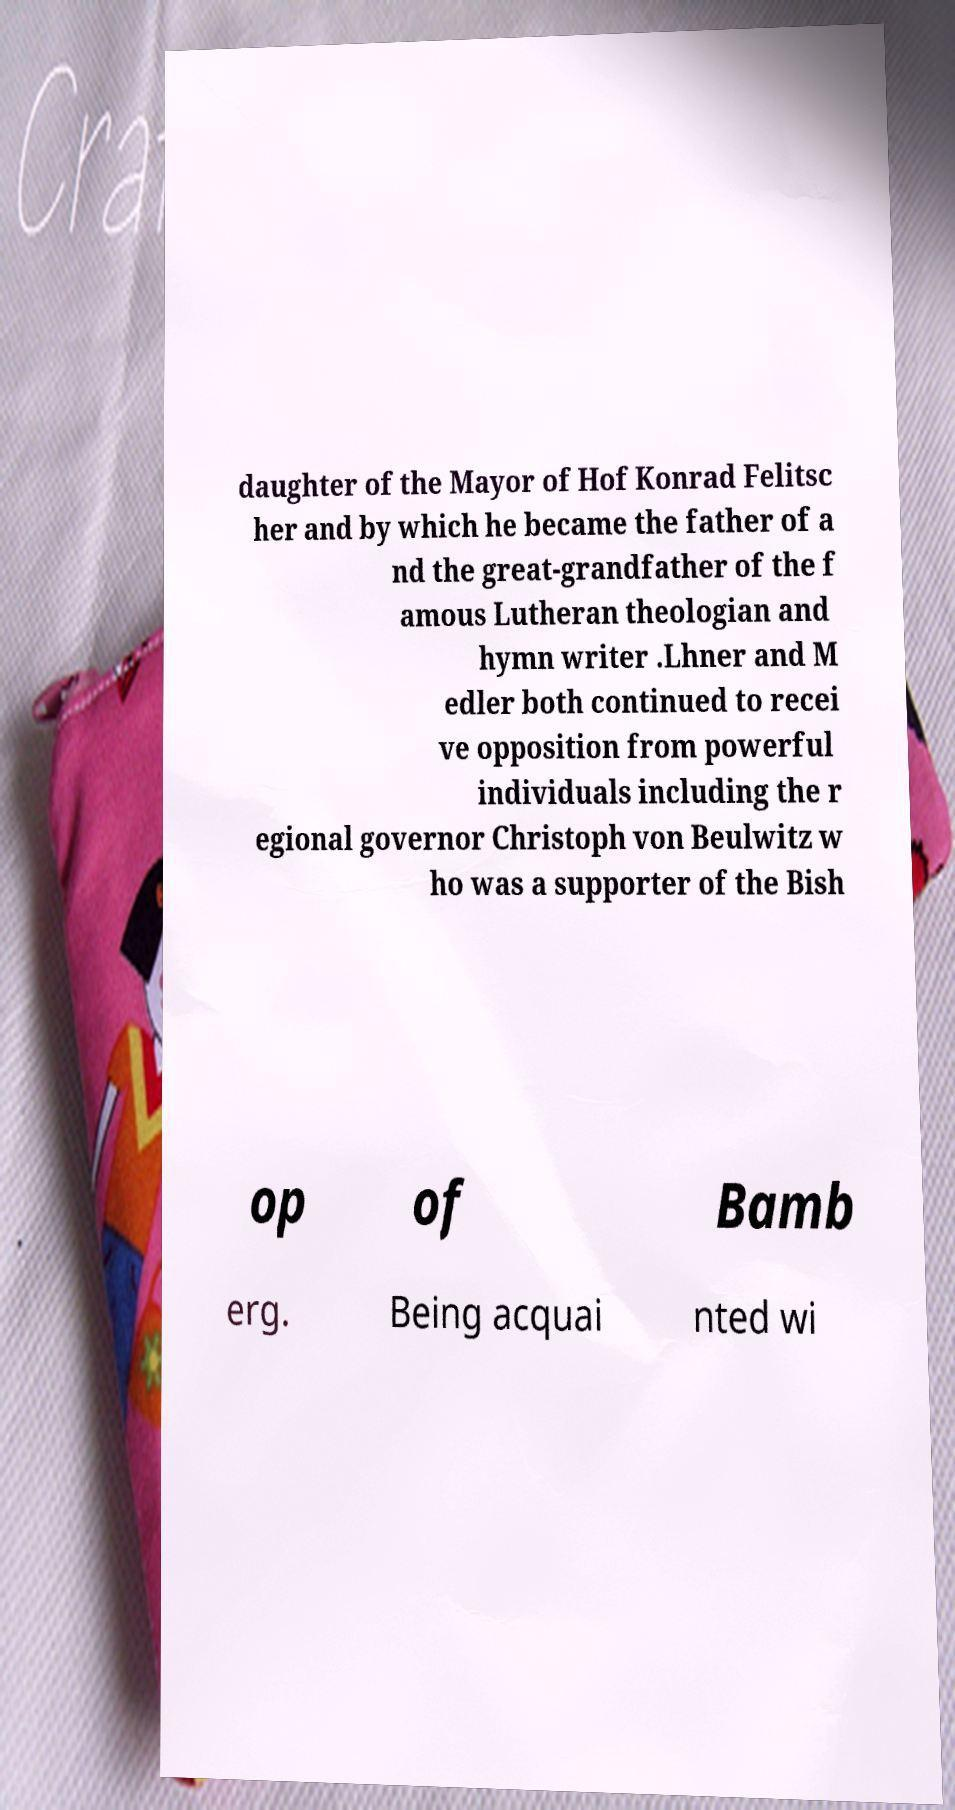Could you assist in decoding the text presented in this image and type it out clearly? daughter of the Mayor of Hof Konrad Felitsc her and by which he became the father of a nd the great-grandfather of the f amous Lutheran theologian and hymn writer .Lhner and M edler both continued to recei ve opposition from powerful individuals including the r egional governor Christoph von Beulwitz w ho was a supporter of the Bish op of Bamb erg. Being acquai nted wi 